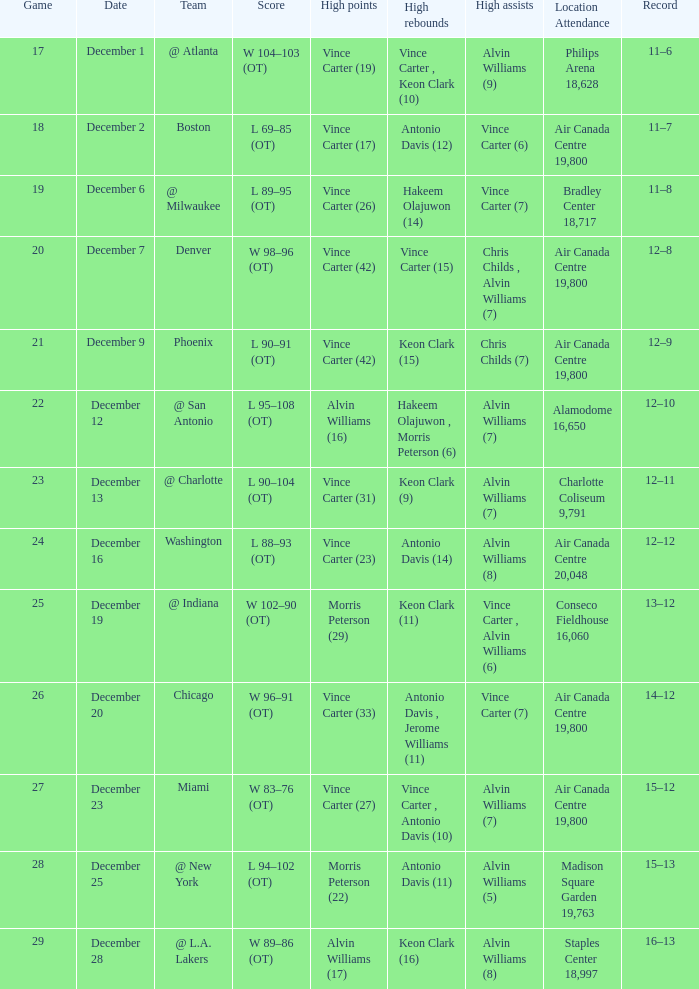What game happened on December 19? 25.0. 